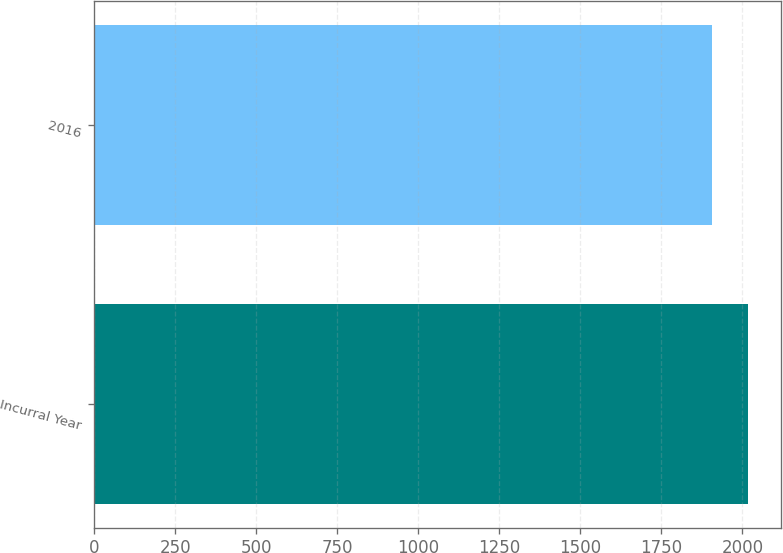<chart> <loc_0><loc_0><loc_500><loc_500><bar_chart><fcel>Incurral Year<fcel>2016<nl><fcel>2018<fcel>1906<nl></chart> 